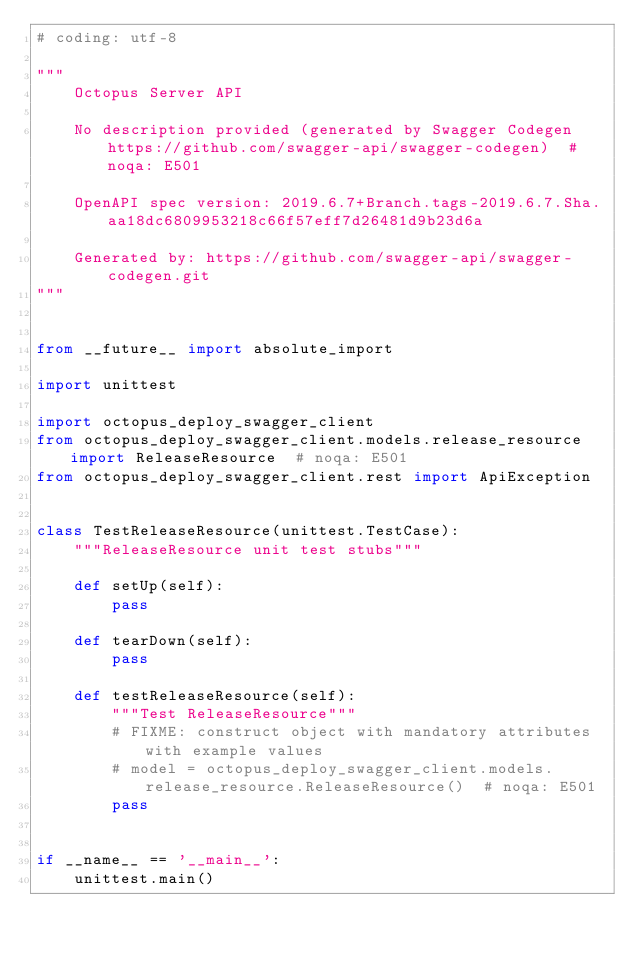<code> <loc_0><loc_0><loc_500><loc_500><_Python_># coding: utf-8

"""
    Octopus Server API

    No description provided (generated by Swagger Codegen https://github.com/swagger-api/swagger-codegen)  # noqa: E501

    OpenAPI spec version: 2019.6.7+Branch.tags-2019.6.7.Sha.aa18dc6809953218c66f57eff7d26481d9b23d6a
    
    Generated by: https://github.com/swagger-api/swagger-codegen.git
"""


from __future__ import absolute_import

import unittest

import octopus_deploy_swagger_client
from octopus_deploy_swagger_client.models.release_resource import ReleaseResource  # noqa: E501
from octopus_deploy_swagger_client.rest import ApiException


class TestReleaseResource(unittest.TestCase):
    """ReleaseResource unit test stubs"""

    def setUp(self):
        pass

    def tearDown(self):
        pass

    def testReleaseResource(self):
        """Test ReleaseResource"""
        # FIXME: construct object with mandatory attributes with example values
        # model = octopus_deploy_swagger_client.models.release_resource.ReleaseResource()  # noqa: E501
        pass


if __name__ == '__main__':
    unittest.main()
</code> 